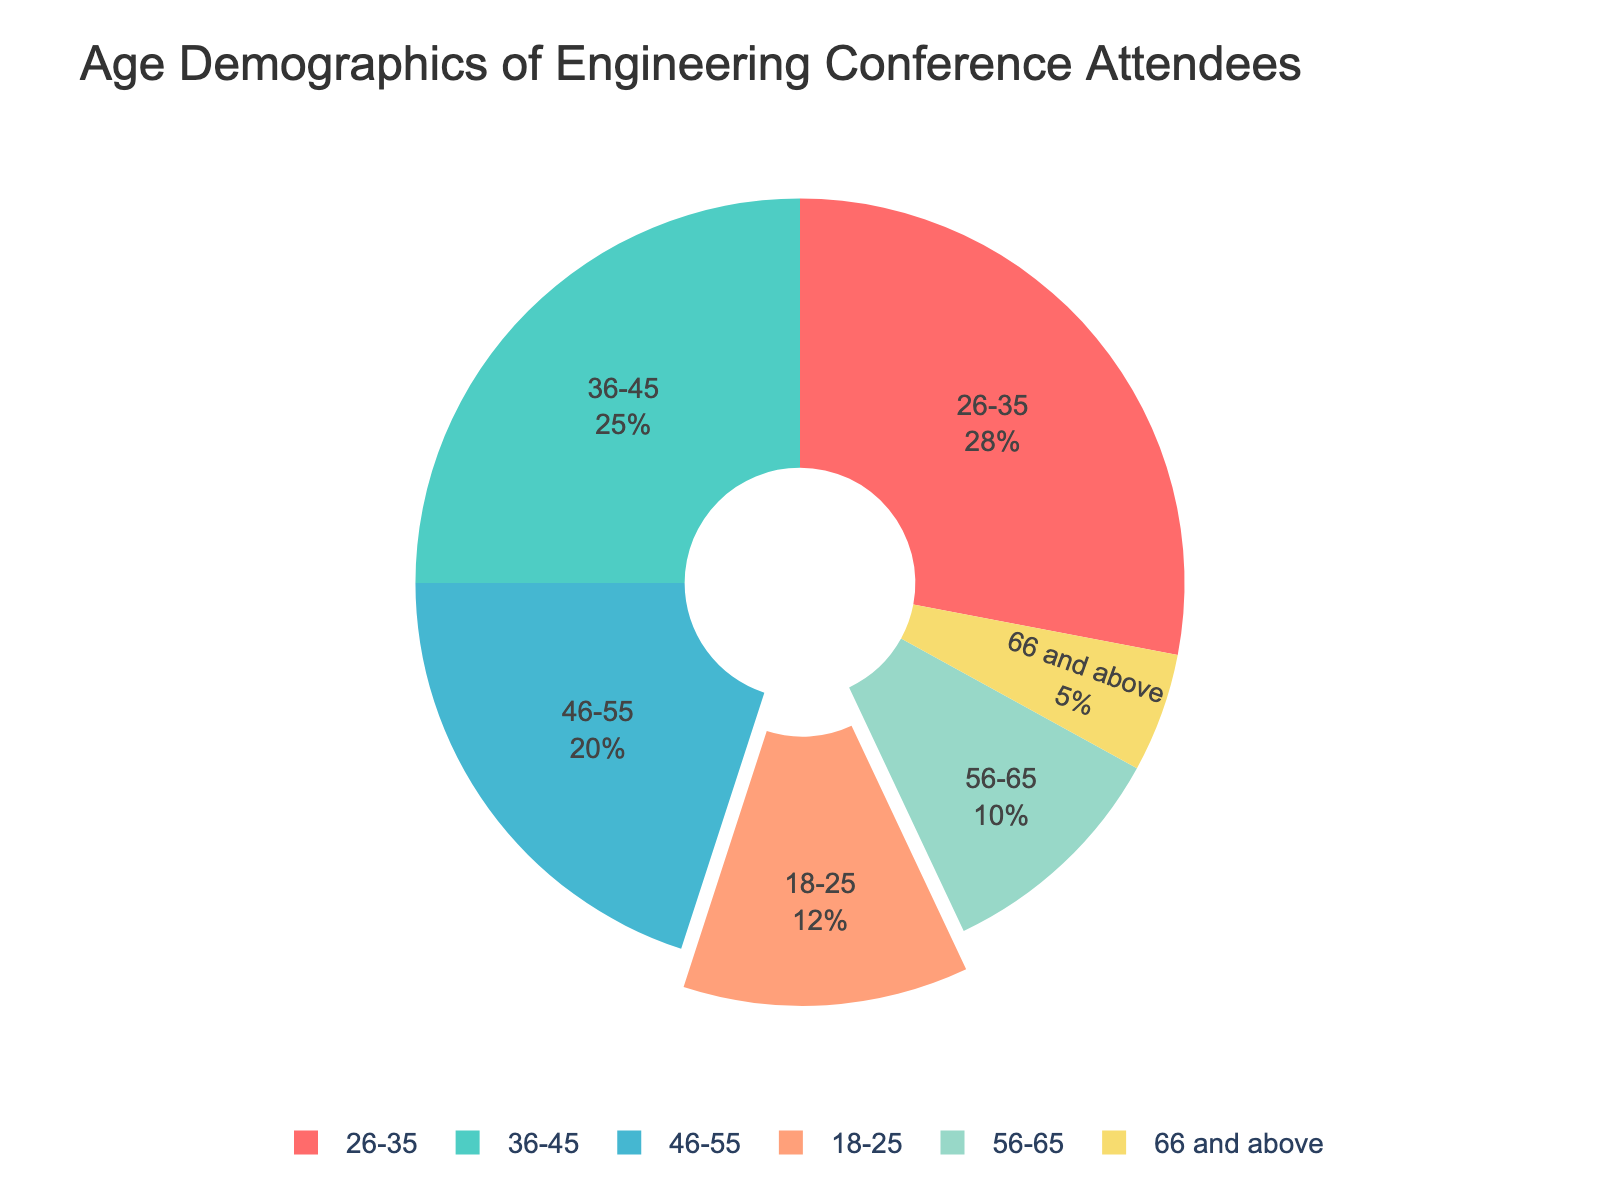What's the largest age group attending the conferences? The figure indicates segments representing different age groups and their respective percentages. We can observe that the age group with the largest percentage is 26-35.
Answer: 26-35 Which age group has the lowest representation at the conferences? By examining the smallest segment in the pie chart, we see that the age group 66 and above has the lowest percentage.
Answer: 66 and above What is the total percentage of attendees aged 36-55? To find the total percentage for the age groups 36-45 and 46-55, sum the individual percentages: 25% (36-45) + 20% (46-55) = 45%.
Answer: 45% How does the percentage of the youngest age group (18-25) compare to the oldest age group (66 and above)? The youngest age group (18-25) shows 12%, while the oldest age group (66 and above) is 5%. Comparing these values, 12% is more than twice the percentage of 5%.
Answer: 12% is more than twice 5% Which age group falls directly in the middle in terms of representation? Arranging the age groups by percentage: 66 and above (5%), 56-65 (10%), 18-25 (12%), 46-55 (20%), 36-45 (25%), and 26-35 (28%), we see that 36-45 falls exactly in the middle.
Answer: 36-45 What proportion of attendees are aged above 45? To calculate the proportion above 45, sum the percentages of 46-55, 56-65, and 66 and above: 20% + 10% + 5% = 35%.
Answer: 35% If combined, do the youngest two age groups (18-25 and 26-35) make up more than 50% of the attendees? Adding the percentages of 18-25 and 26-35: 12% + 28% = 40%. This is less than 50%.
Answer: No What color represents the age group 36-45 on the pie chart? According to the custom color palette used, the segment for the age group 36-45 is depicted in a shade of sky blue.
Answer: Sky blue How does the 46-55 age group compare in size with the 56-65 age group? The pie chart shows that the percent for the 46-55 age group is 20%, while the 56-65 age group is 10%. Thus, 46-55 is twice the size of 56-65.
Answer: Twice the size Calculate the difference between the combined percentage of attendees aged 46-65 and those aged 18-25. First, find the combined percentage of attendees aged 46-65: 20% (46-55) + 10% (56-65) = 30%. Then, subtract the percentage for 18-25: 30% - 12% = 18%.
Answer: 18% 